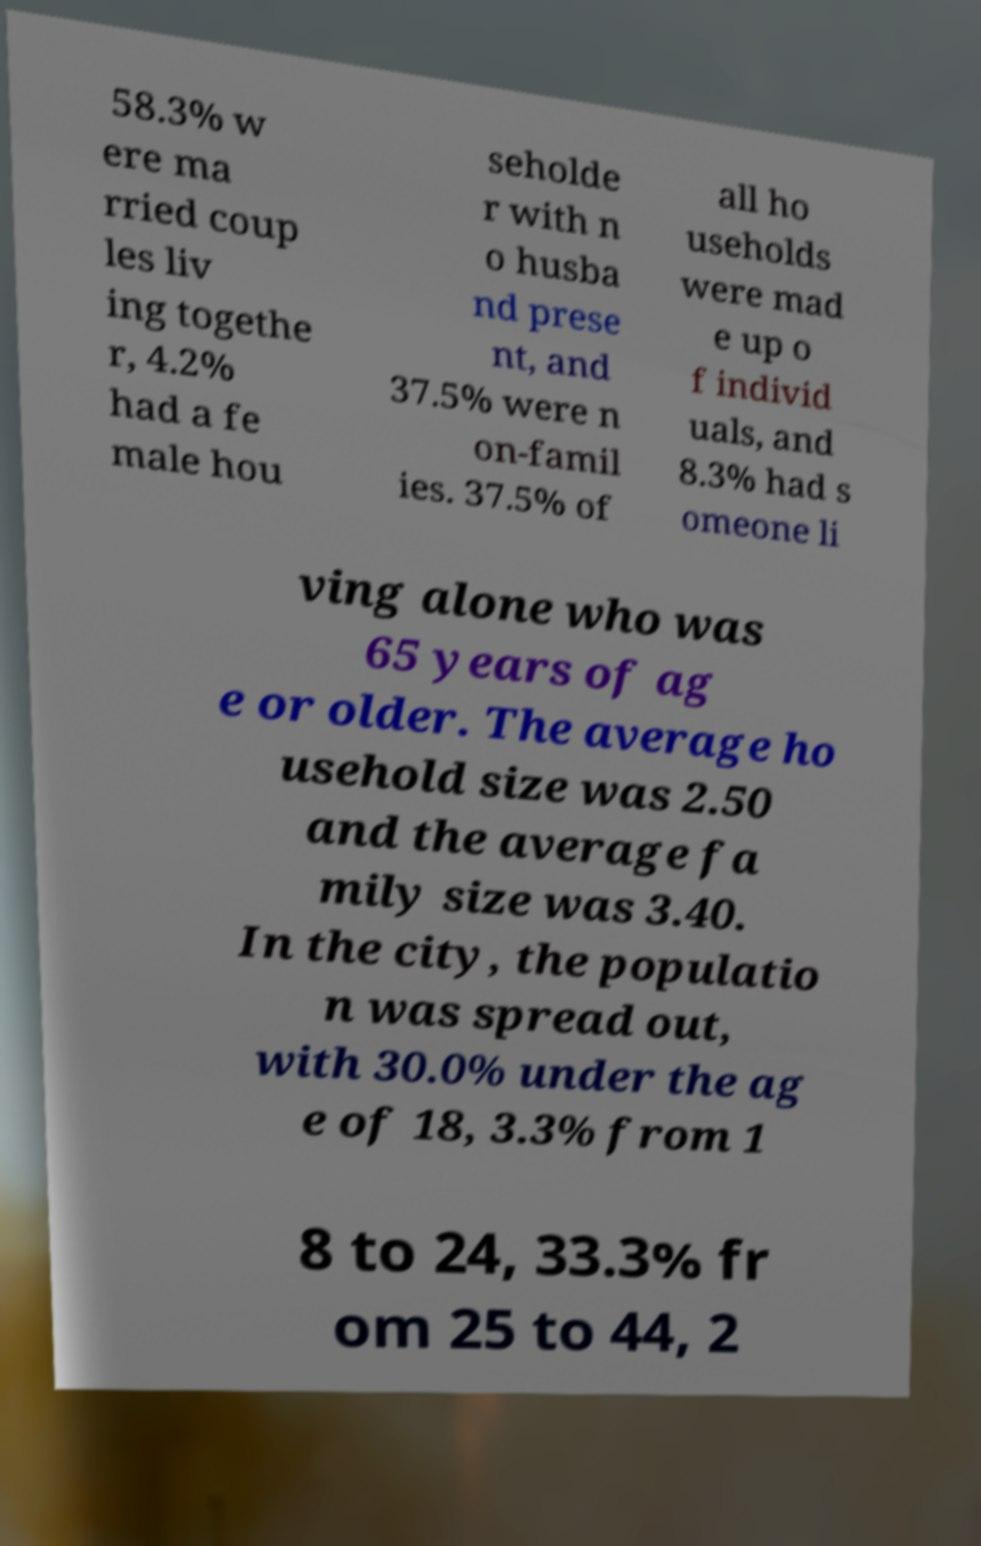For documentation purposes, I need the text within this image transcribed. Could you provide that? 58.3% w ere ma rried coup les liv ing togethe r, 4.2% had a fe male hou seholde r with n o husba nd prese nt, and 37.5% were n on-famil ies. 37.5% of all ho useholds were mad e up o f individ uals, and 8.3% had s omeone li ving alone who was 65 years of ag e or older. The average ho usehold size was 2.50 and the average fa mily size was 3.40. In the city, the populatio n was spread out, with 30.0% under the ag e of 18, 3.3% from 1 8 to 24, 33.3% fr om 25 to 44, 2 